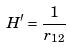<formula> <loc_0><loc_0><loc_500><loc_500>H ^ { \prime } = \frac { 1 } { r _ { 1 2 } }</formula> 